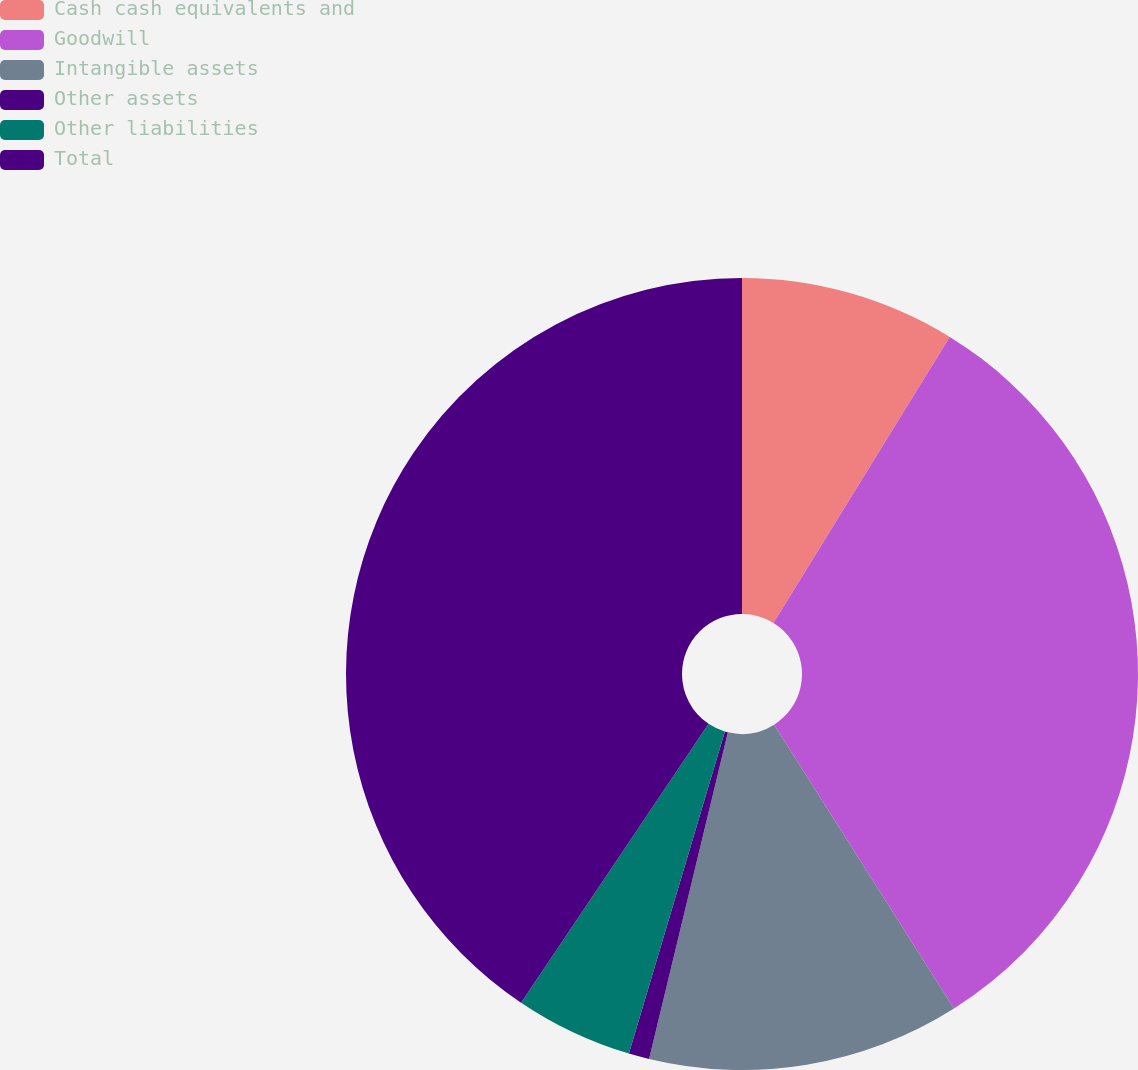Convert chart to OTSL. <chart><loc_0><loc_0><loc_500><loc_500><pie_chart><fcel>Cash cash equivalents and<fcel>Goodwill<fcel>Intangible assets<fcel>Other assets<fcel>Other liabilities<fcel>Total<nl><fcel>8.79%<fcel>32.22%<fcel>12.76%<fcel>0.84%<fcel>4.81%<fcel>40.58%<nl></chart> 